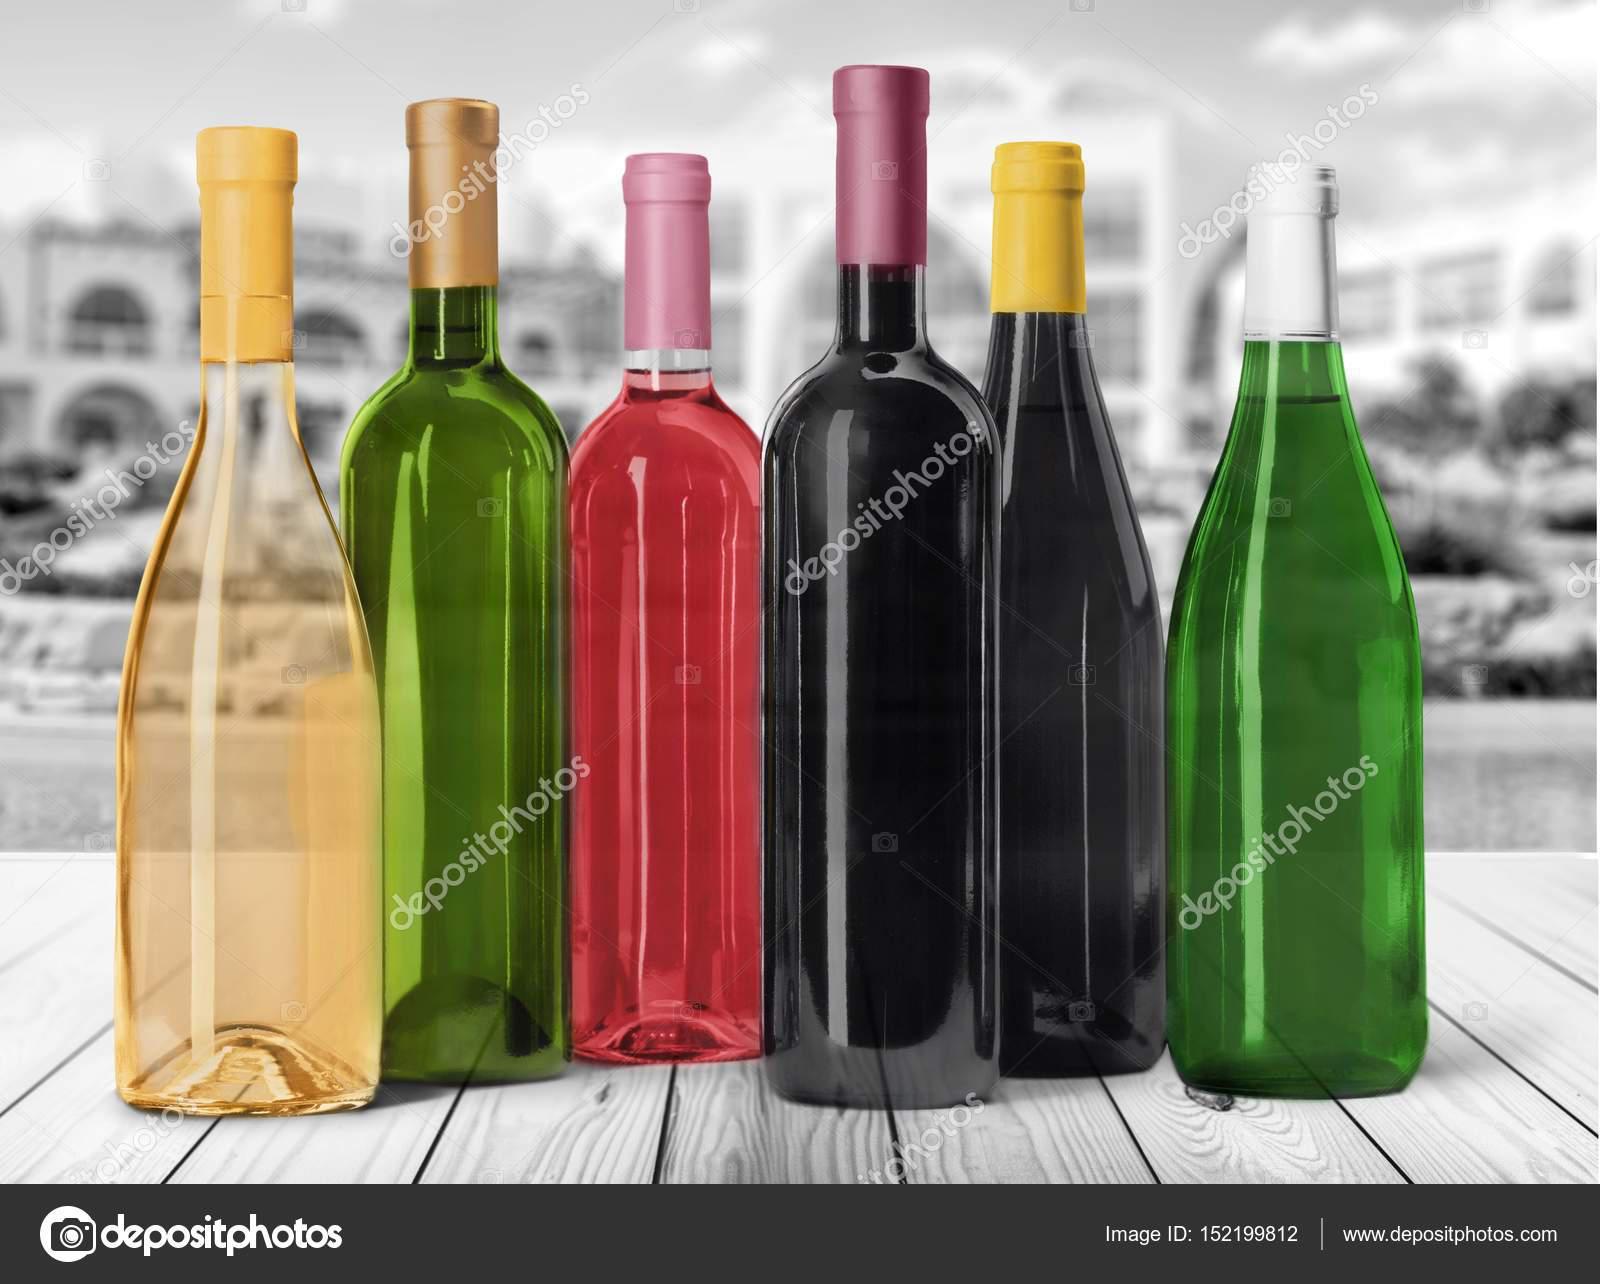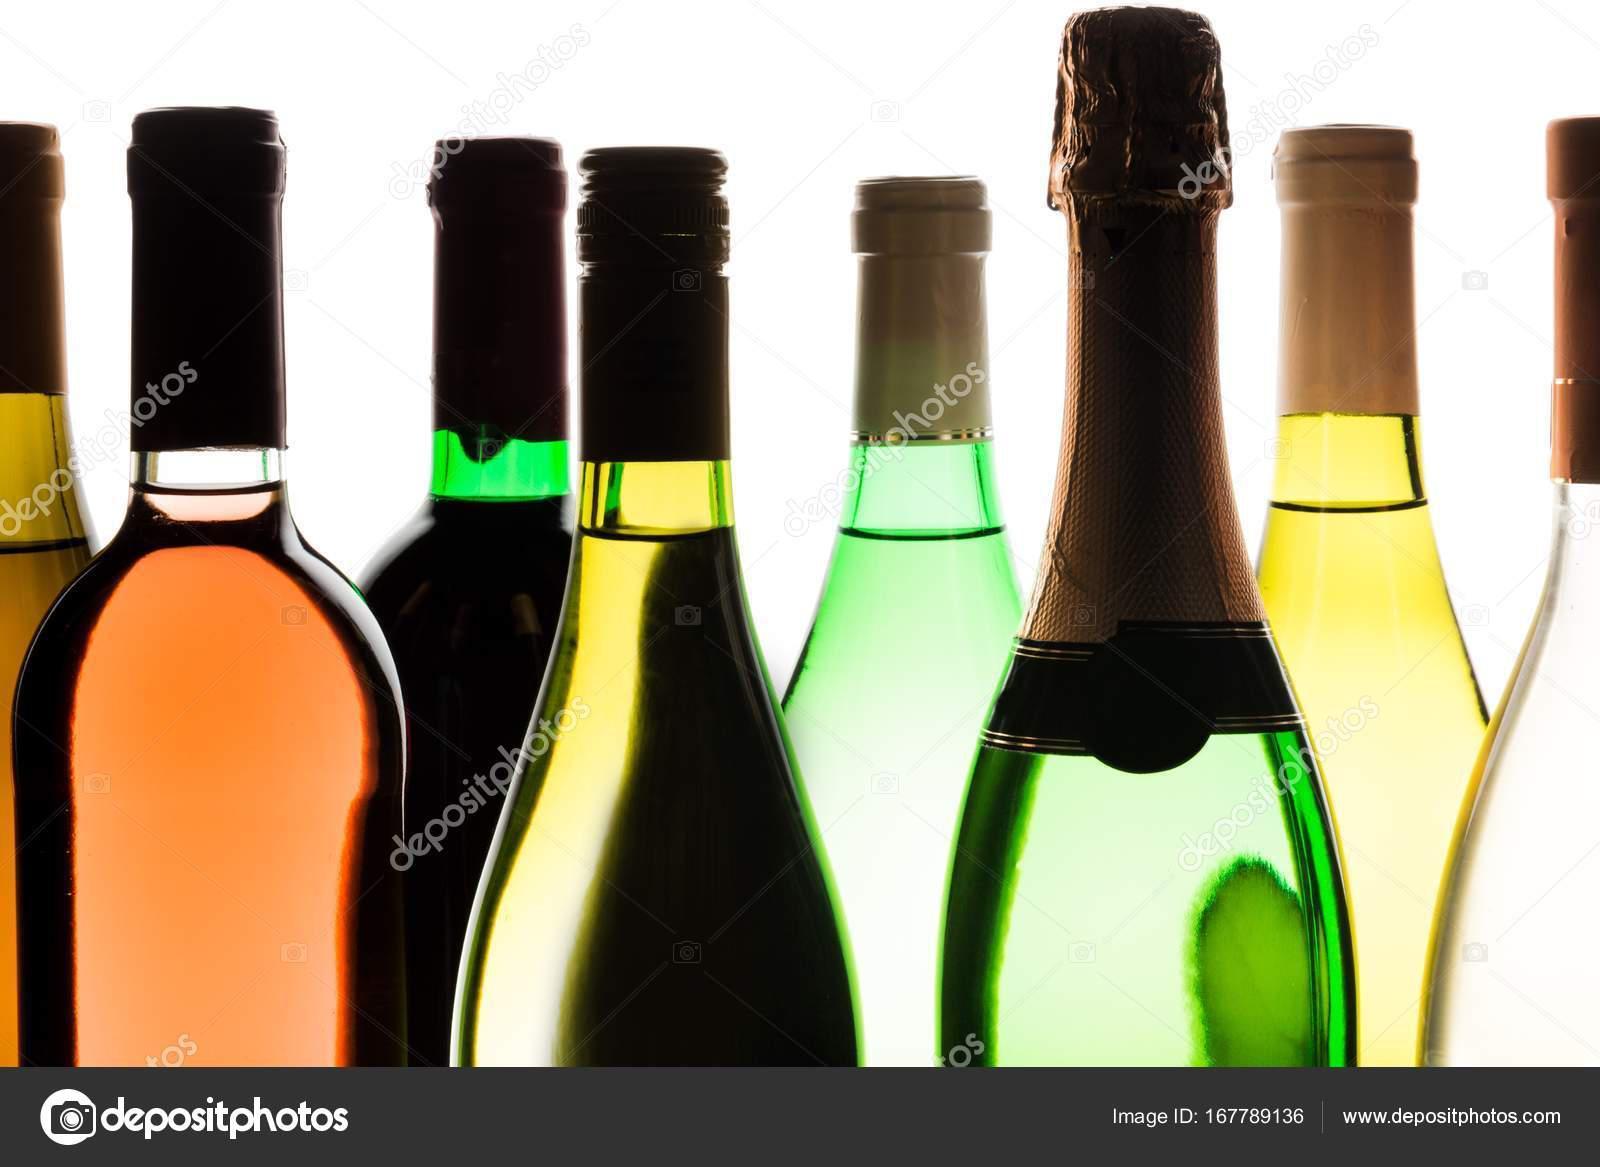The first image is the image on the left, the second image is the image on the right. Considering the images on both sides, is "There are more bottles in the right image than in the left image." valid? Answer yes or no. Yes. The first image is the image on the left, the second image is the image on the right. For the images shown, is this caption "There are no more than four bottles in one of the images." true? Answer yes or no. No. 